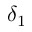Convert formula to latex. <formula><loc_0><loc_0><loc_500><loc_500>\delta _ { 1 }</formula> 